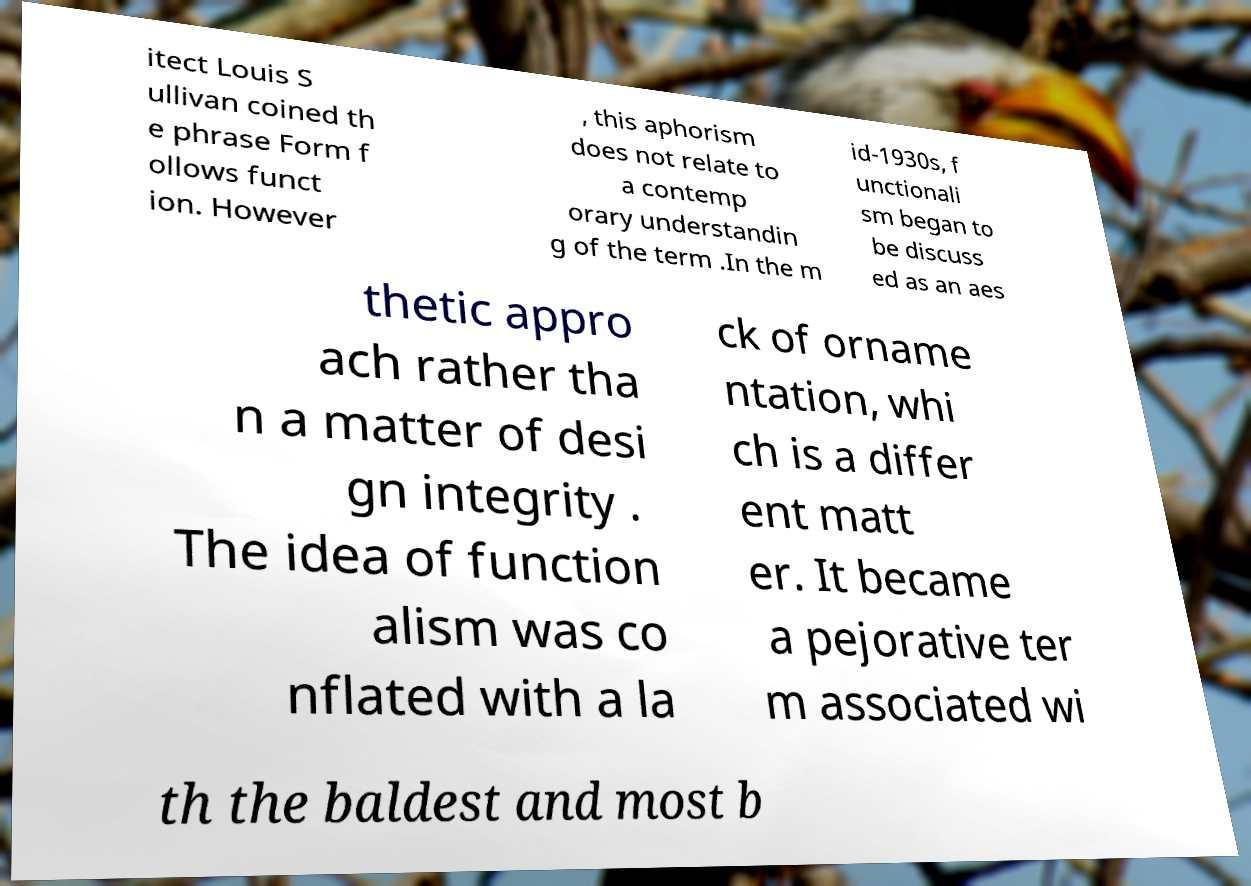Can you read and provide the text displayed in the image?This photo seems to have some interesting text. Can you extract and type it out for me? itect Louis S ullivan coined th e phrase Form f ollows funct ion. However , this aphorism does not relate to a contemp orary understandin g of the term .In the m id-1930s, f unctionali sm began to be discuss ed as an aes thetic appro ach rather tha n a matter of desi gn integrity . The idea of function alism was co nflated with a la ck of orname ntation, whi ch is a differ ent matt er. It became a pejorative ter m associated wi th the baldest and most b 